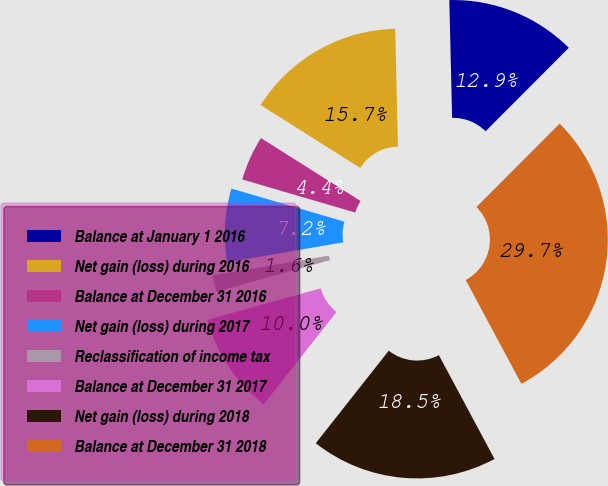Convert chart to OTSL. <chart><loc_0><loc_0><loc_500><loc_500><pie_chart><fcel>Balance at January 1 2016<fcel>Net gain (loss) during 2016<fcel>Balance at December 31 2016<fcel>Net gain (loss) during 2017<fcel>Reclassification of income tax<fcel>Balance at December 31 2017<fcel>Net gain (loss) during 2018<fcel>Balance at December 31 2018<nl><fcel>12.85%<fcel>15.66%<fcel>4.43%<fcel>7.24%<fcel>1.62%<fcel>10.04%<fcel>18.46%<fcel>29.69%<nl></chart> 